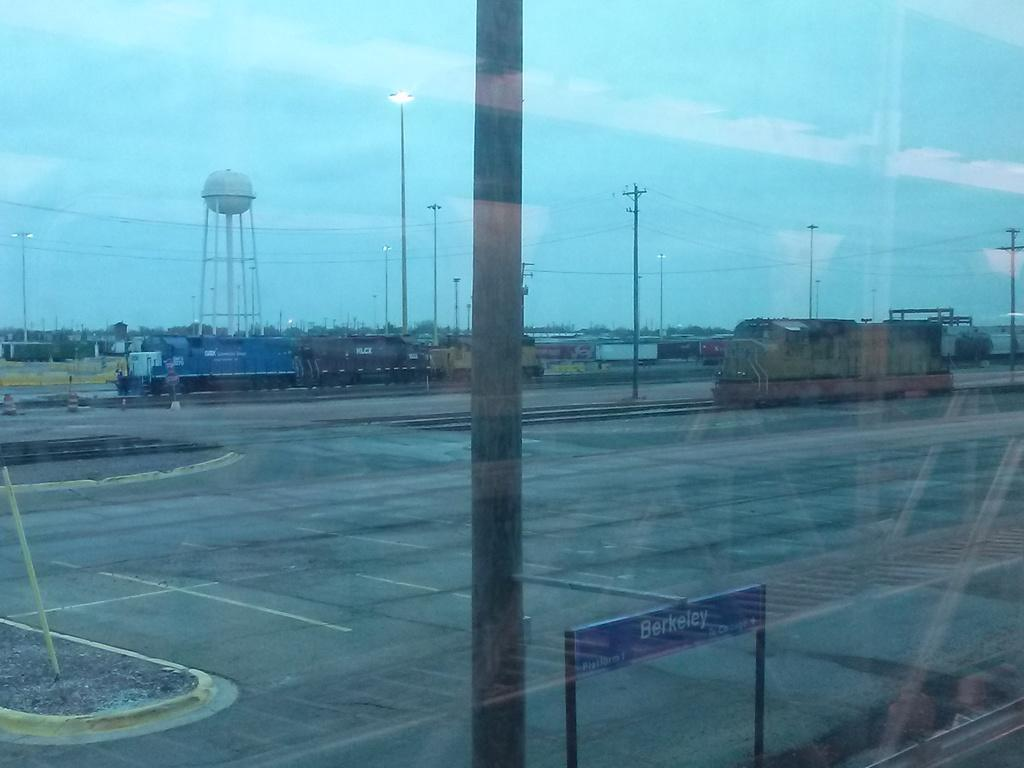Provide a one-sentence caption for the provided image. A sign that says Berkeley stands near a field of train tracks. 